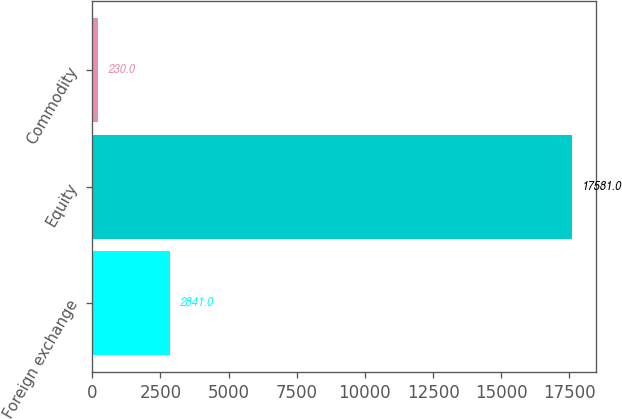Convert chart to OTSL. <chart><loc_0><loc_0><loc_500><loc_500><bar_chart><fcel>Foreign exchange<fcel>Equity<fcel>Commodity<nl><fcel>2841<fcel>17581<fcel>230<nl></chart> 